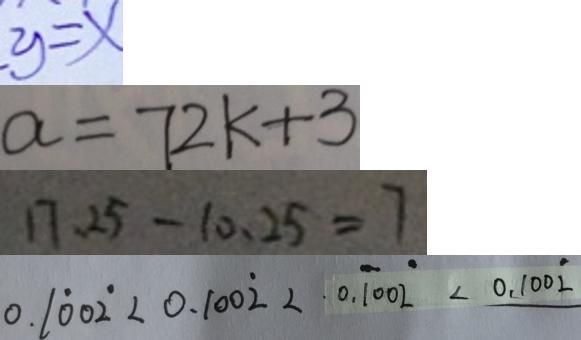<formula> <loc_0><loc_0><loc_500><loc_500>y = x 
 a = 7 2 k + 3 
 1 7 . 2 5 - 1 0 . 2 5 = 7 
 0 . 1 \dot { 0 } 0 \dot { 2 } < 0 . 1 0 0 \dot { 2 } < 0 . \dot { 1 } 0 0 \dot { 2 } < 0 . 1 0 0 \dot { 2 }</formula> 